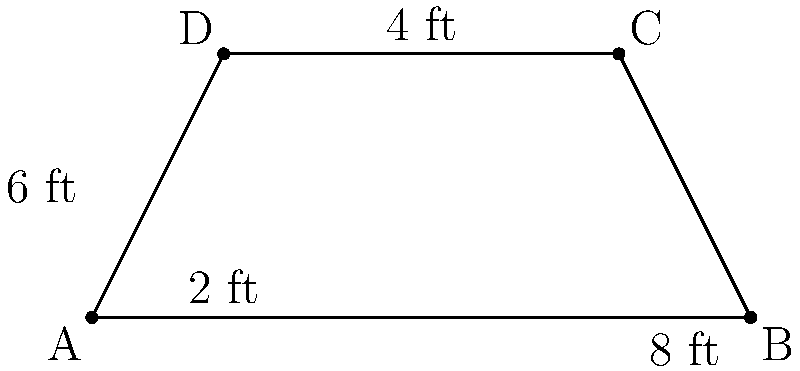You're designing a custom mixing console for your studio that incorporates traditional Ghanaian drum patterns. The console has a unique trapezoid shape to fit your workspace. If the parallel sides of the trapezoid-shaped console measure 8 ft and 4 ft, and the height (distance between the parallel sides) is 6 ft, what is the total surface area of the mixing console in square feet? To find the area of a trapezoid, we can use the formula:

$$A = \frac{1}{2}(b_1 + b_2)h$$

Where:
$A$ = Area
$b_1$ and $b_2$ = Lengths of the parallel sides
$h$ = Height (perpendicular distance between the parallel sides)

Given:
$b_1 = 8$ ft (longer parallel side)
$b_2 = 4$ ft (shorter parallel side)
$h = 6$ ft (height)

Let's substitute these values into the formula:

$$A = \frac{1}{2}(8 + 4) \times 6$$

Simplify:
$$A = \frac{1}{2}(12) \times 6$$
$$A = 6 \times 6$$
$$A = 36$$

Therefore, the total surface area of the mixing console is 36 square feet.
Answer: 36 sq ft 